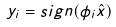Convert formula to latex. <formula><loc_0><loc_0><loc_500><loc_500>y _ { i } = s i g n ( \phi _ { i } \hat { x } )</formula> 